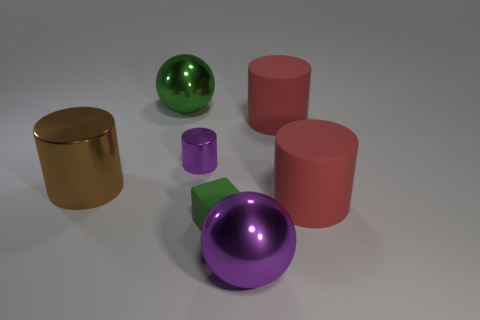Subtract all large cylinders. How many cylinders are left? 1 Add 2 red matte objects. How many objects exist? 9 Subtract all green spheres. How many spheres are left? 1 Subtract all spheres. How many objects are left? 5 Add 4 brown shiny things. How many brown shiny things are left? 5 Add 1 big brown cylinders. How many big brown cylinders exist? 2 Subtract 0 brown cubes. How many objects are left? 7 Subtract 2 balls. How many balls are left? 0 Subtract all yellow cylinders. Subtract all green balls. How many cylinders are left? 4 Subtract all cyan cubes. How many green spheres are left? 1 